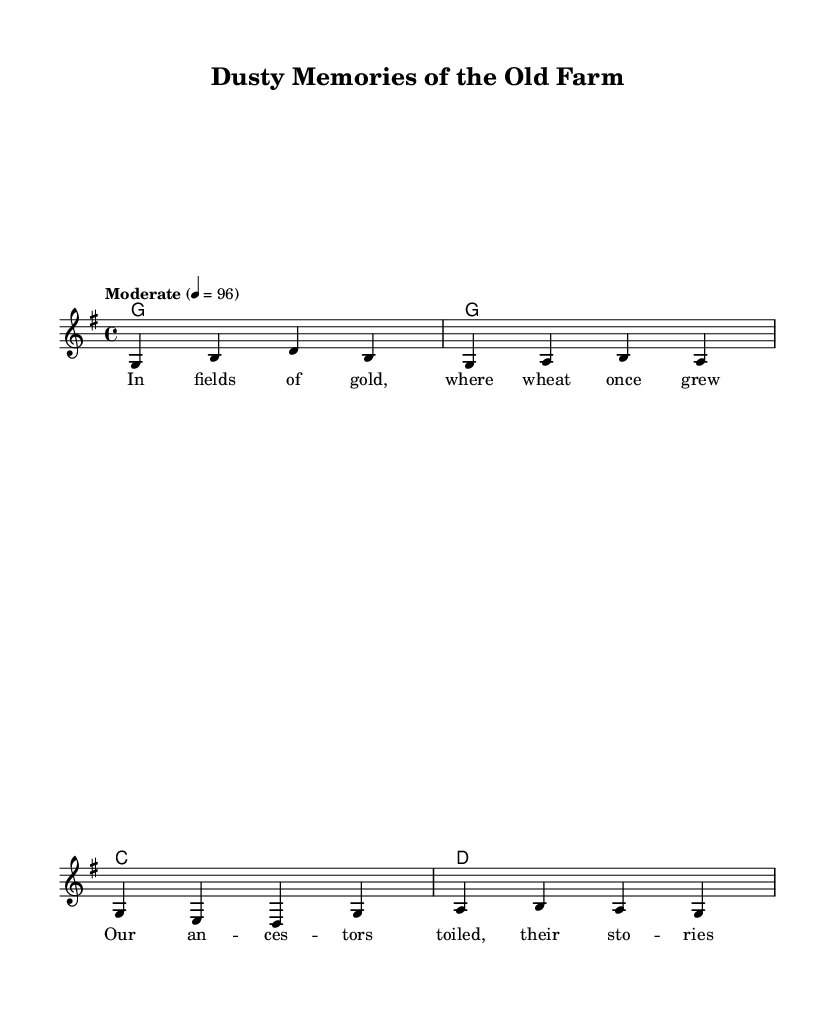What is the key signature of this music? The key signature is G major, which has one sharp (F#). This can be identified by looking at the key signature indicated at the beginning of the sheet music.
Answer: G major What is the time signature of this music? The time signature is 4/4, represented by the fraction showing four beats in a measure and a quarter note gets one beat. It is found right next to the clef at the start of the score.
Answer: 4/4 What is the tempo marking of this music? The tempo marking is "Moderate," which implies a moderate speed for the piece. This information is usually found in the tempo indication, noted at the beginning of the score.
Answer: Moderate How many measures are in the melody section? There are four measures in the melody section, as counted from the beginning to the end of the melody notated in the score. Each measure is typically marked by vertical lines separating the rhythmic groupings.
Answer: Four What is the first chord in the harmony? The first chord in the harmony is G major, which can be identified from the chord symbols placed above the melody. The symbol for G major is denoted by the letter "G."
Answer: G major What type of topics do the lyrics of this song address? The lyrics address the historical toil of ancestors in farming, as indicated by phrases like "fields of gold" and "where wheat once grew," indicating a focus on agricultural life and memories.
Answer: Farming What does the use of a moderate tempo imply about the feel of the song? A moderate tempo suggests a relaxed, reflective feel to the song, allowing the listener to absorb the lyrics and melody, which is characteristic of country music that often narrates stories and memories from rural life.
Answer: Reflective 